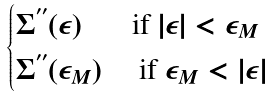Convert formula to latex. <formula><loc_0><loc_0><loc_500><loc_500>\begin{cases} \Sigma ^ { ^ { \prime \prime } } ( \epsilon ) & \text {if $|\epsilon|<\epsilon_{M}$} \\ \Sigma ^ { ^ { \prime \prime } } ( \epsilon _ { M } ) & \text { if $\epsilon_{M}<|\epsilon|$ } \end{cases}</formula> 